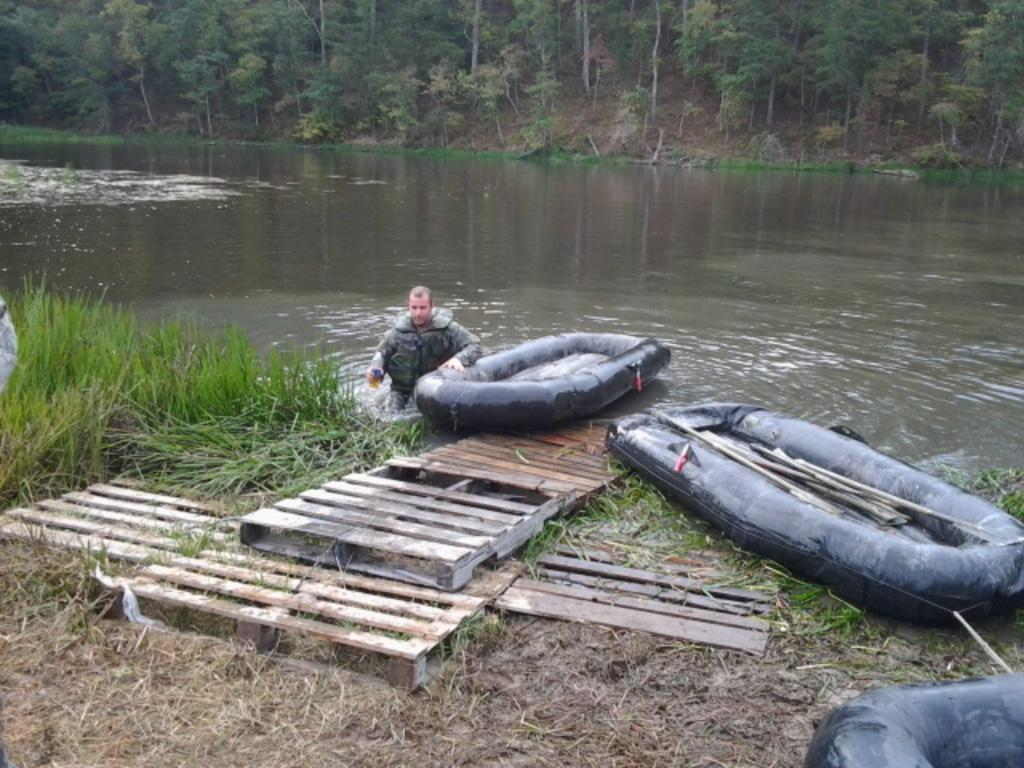What type of boats are in the image? There are tube boats in the image. What material are the objects in the image made of? The objects in the image are made of wood. What is happening in the background of the image? There is a person in the water and trees and grass in the background of the image. What color is the grass in the image? The grass is green in color. What sign is the person holding in the image? There is no sign present in the image; the person is simply in the water. What type of grip does the front of the tube boat have? The tube boats in the image do not have a grip on the front, as they are inflatable and do not have a distinct front or back. 